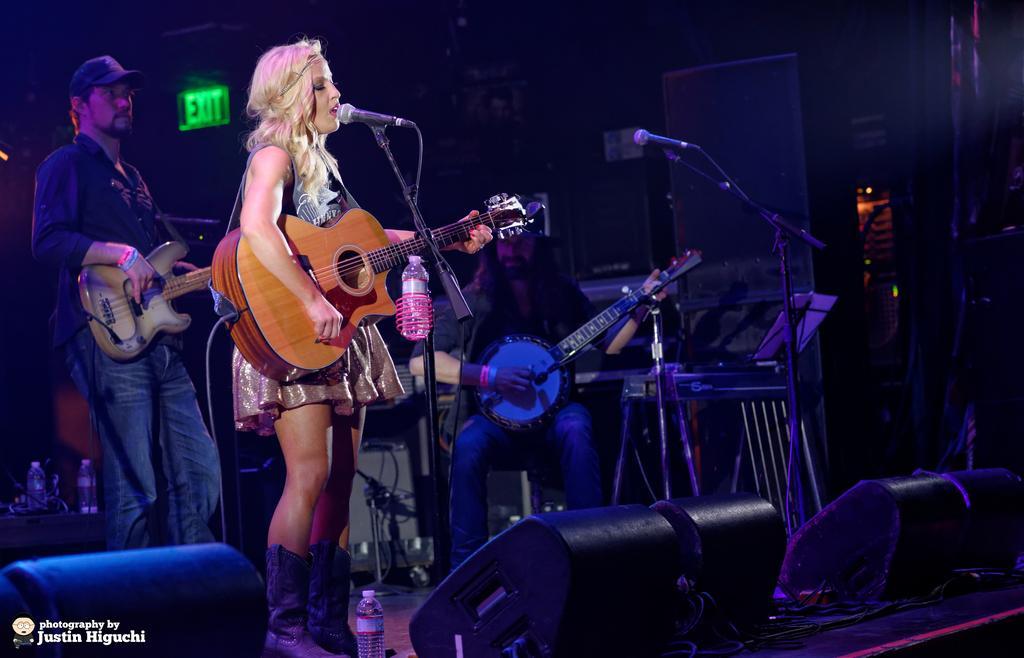Please provide a concise description of this image. In this image on the left side there is one woman who is standing and she is holding a guitar. In front of her there is one mike it seems that she is singing. On the left side there is one person who is holding a guitar and he is wearing a cap, in the middle of the image there is one person who is sitting and he is holding a guitar, and on the right side of the image there is one mike and in the bottom of the image there is one bottle and stage and some lights are there on the bottom of the image. On the left side there are two bottles. 